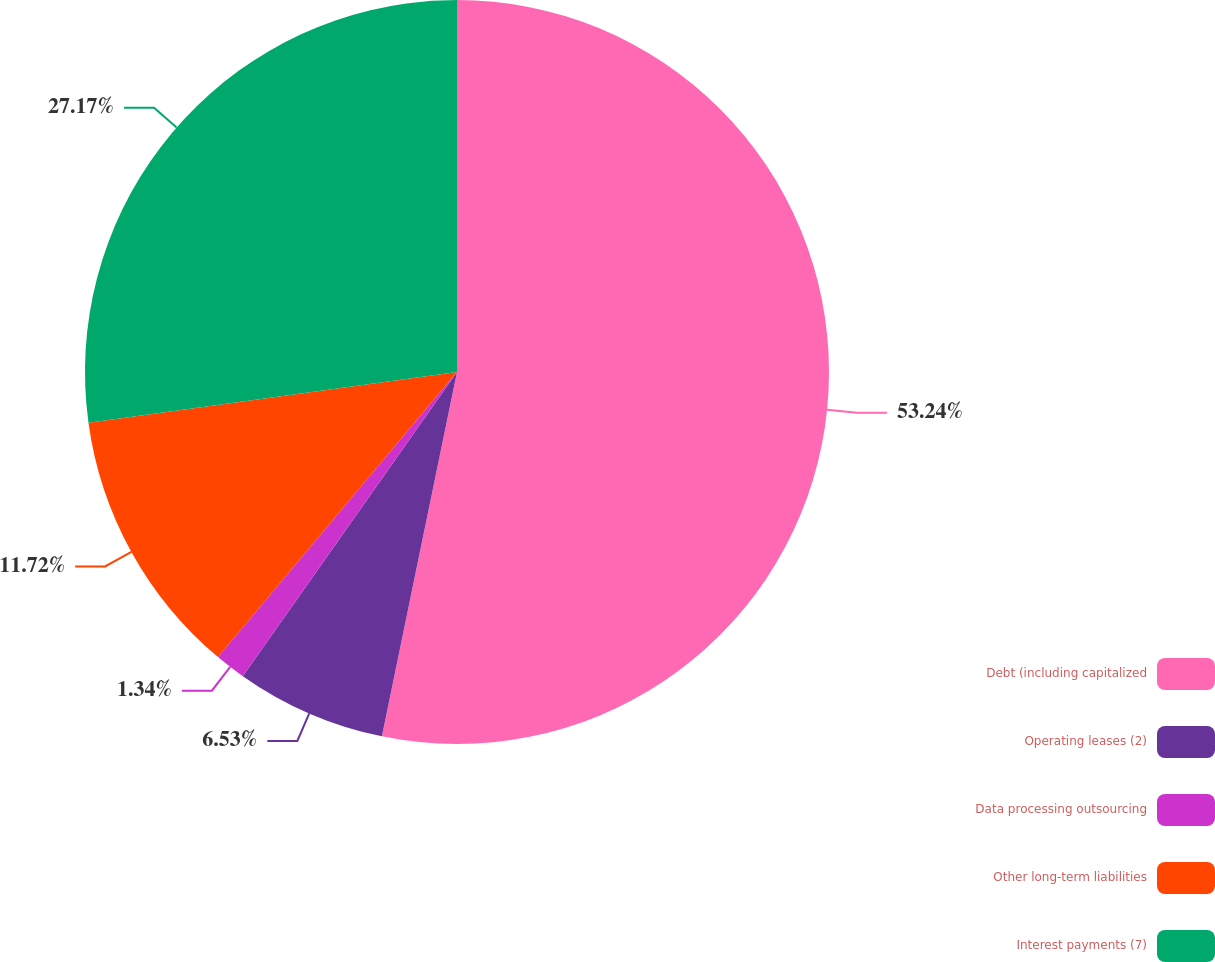Convert chart to OTSL. <chart><loc_0><loc_0><loc_500><loc_500><pie_chart><fcel>Debt (including capitalized<fcel>Operating leases (2)<fcel>Data processing outsourcing<fcel>Other long-term liabilities<fcel>Interest payments (7)<nl><fcel>53.23%<fcel>6.53%<fcel>1.34%<fcel>11.72%<fcel>27.17%<nl></chart> 